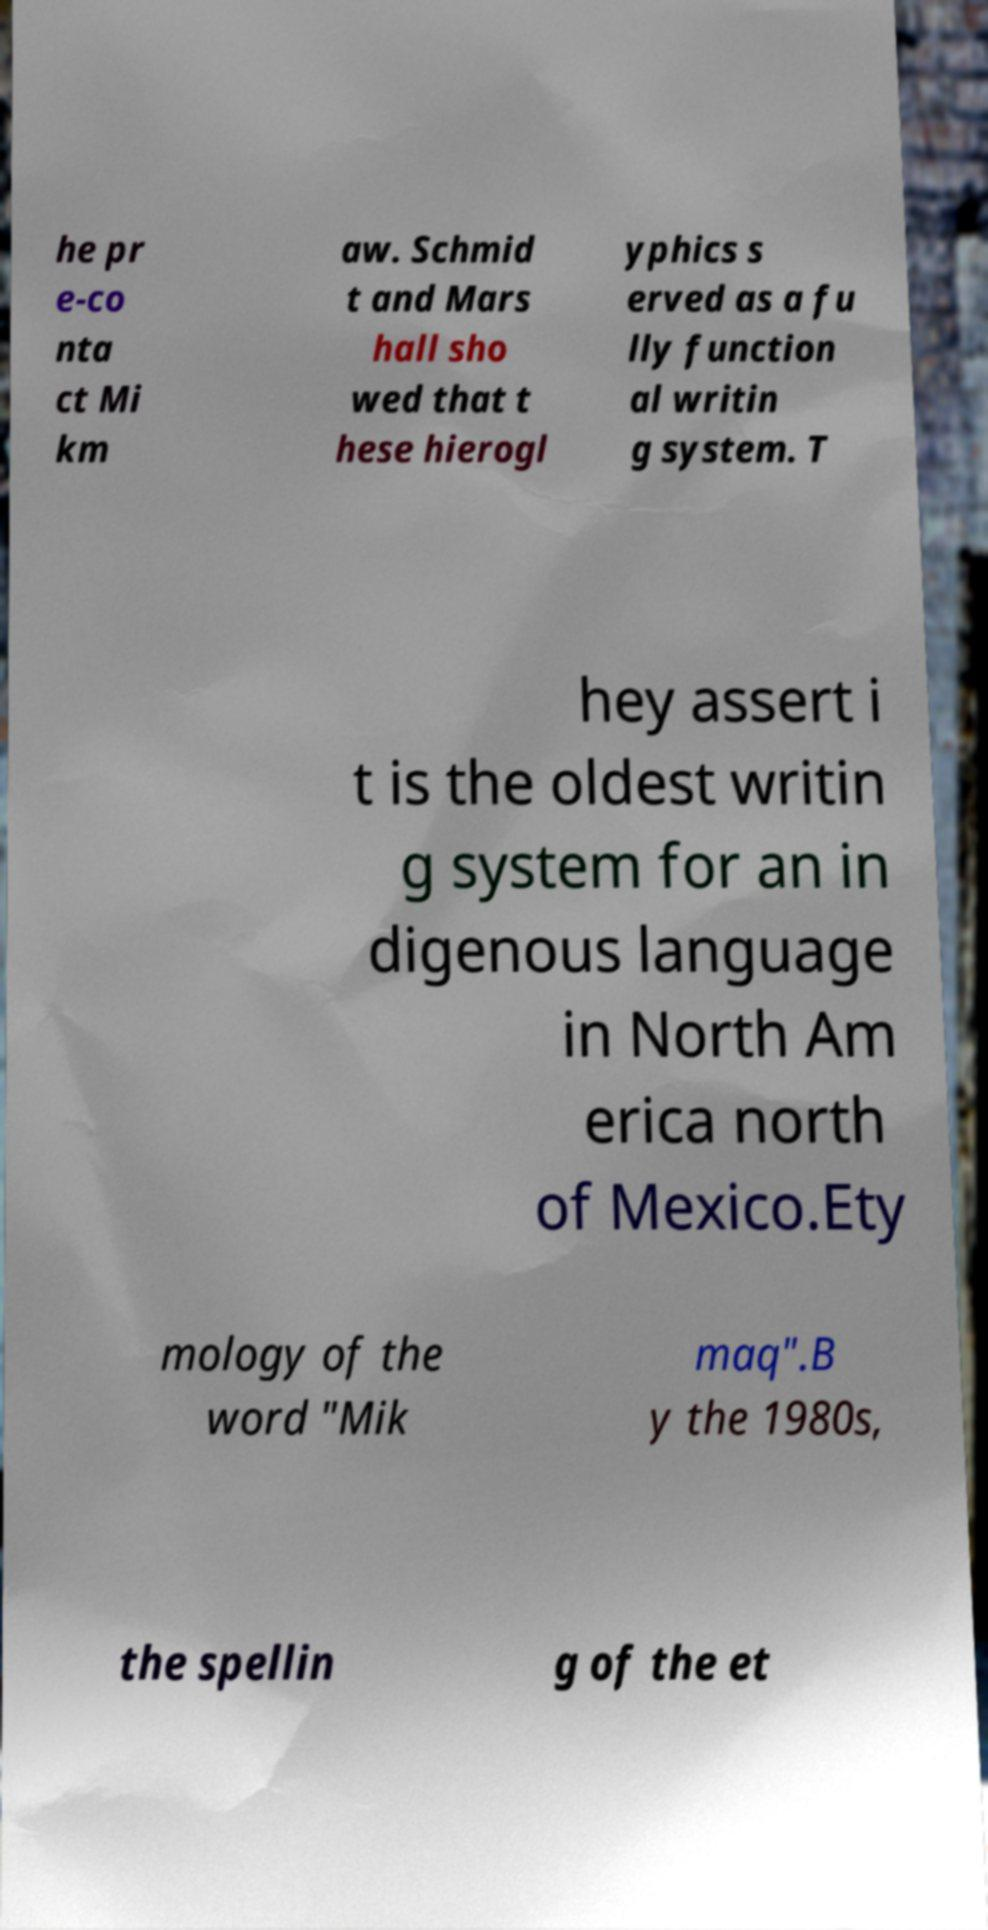For documentation purposes, I need the text within this image transcribed. Could you provide that? he pr e-co nta ct Mi km aw. Schmid t and Mars hall sho wed that t hese hierogl yphics s erved as a fu lly function al writin g system. T hey assert i t is the oldest writin g system for an in digenous language in North Am erica north of Mexico.Ety mology of the word "Mik maq".B y the 1980s, the spellin g of the et 